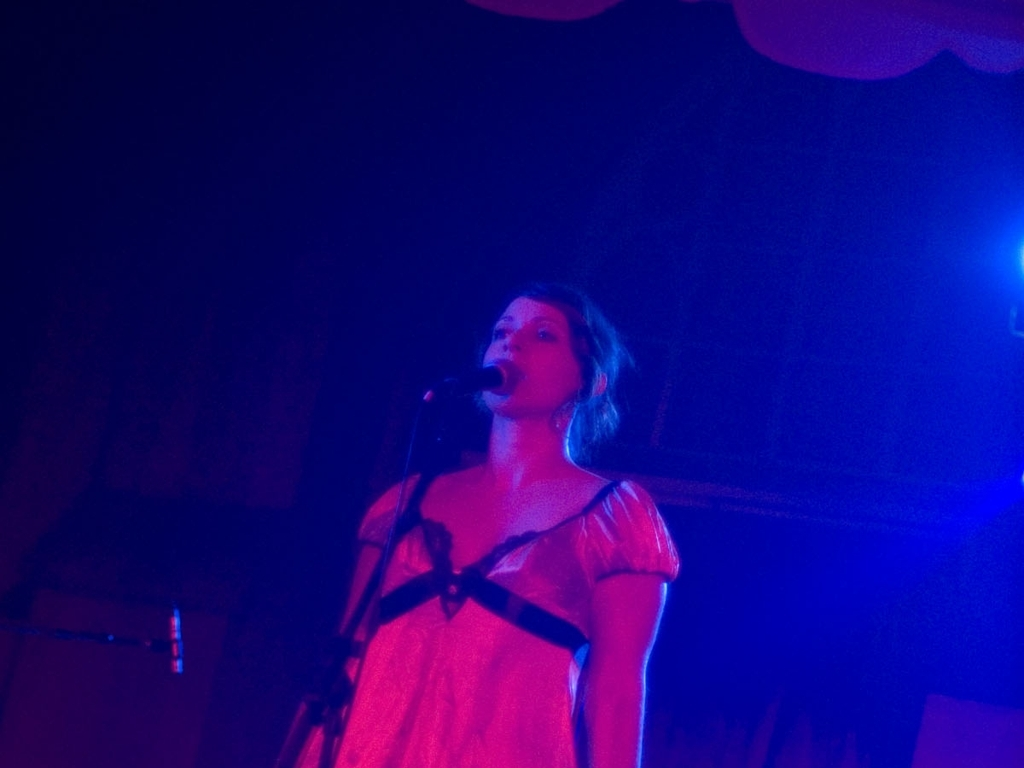What can you infer about the performer's genre or style? Based on the simplicity of the setting and minimalistic attire, the performer's style might lean towards acoustic, indie, or folk music, genres that often focus on the raw emotion and storytelling. 